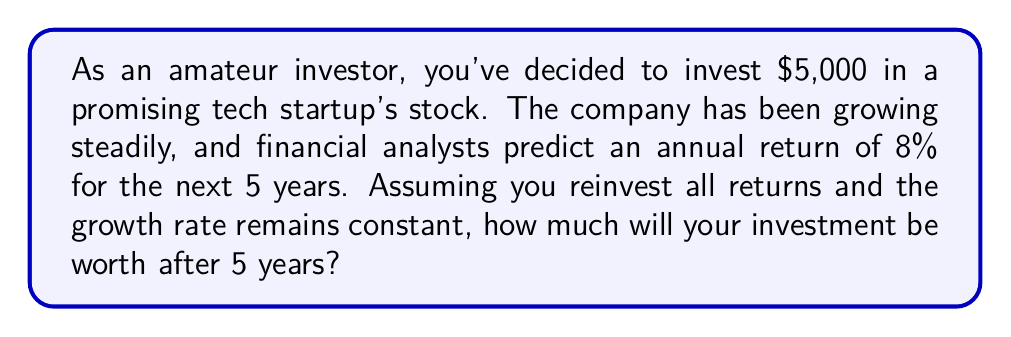Give your solution to this math problem. To solve this problem, we'll use the compound interest formula:

$$A = P(1 + r)^t$$

Where:
$A$ = Final amount
$P$ = Principal (initial investment)
$r$ = Annual interest rate (as a decimal)
$t$ = Time in years

Given:
$P = \$5,000$
$r = 8\% = 0.08$
$t = 5$ years

Let's plug these values into the formula:

$$A = 5000(1 + 0.08)^5$$

Now, let's calculate step by step:

1) First, calculate $(1 + 0.08)$:
   $1 + 0.08 = 1.08$

2) Now, raise 1.08 to the power of 5:
   $1.08^5 \approx 1.4693280768$

3) Finally, multiply this by the principal:
   $5000 \times 1.4693280768 \approx 7346.64$

Therefore, after 5 years, your investment will be worth approximately $7,346.64.
Answer: $7,346.64 